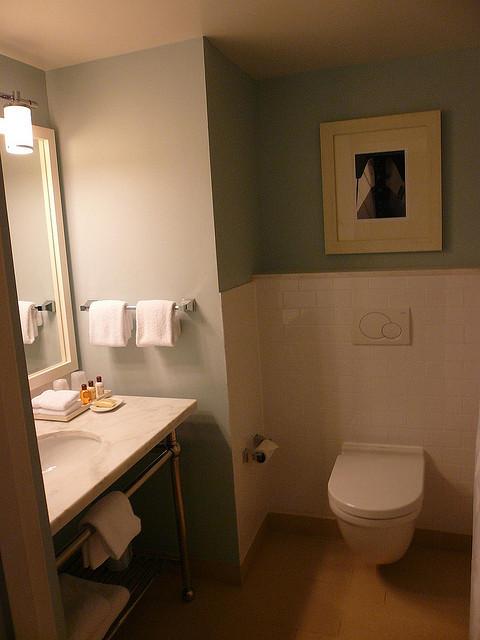What color is the towel?
Be succinct. White. Where are the toiletries?
Write a very short answer. Sink. What room is this?
Write a very short answer. Bathroom. What color are the towels?
Short answer required. White. What is the floor made of?
Keep it brief. Tile. Where is the painting?
Keep it brief. Above toilet. Is there a window in the bathroom?
Quick response, please. No. What is in the bottle?
Write a very short answer. Soap. 